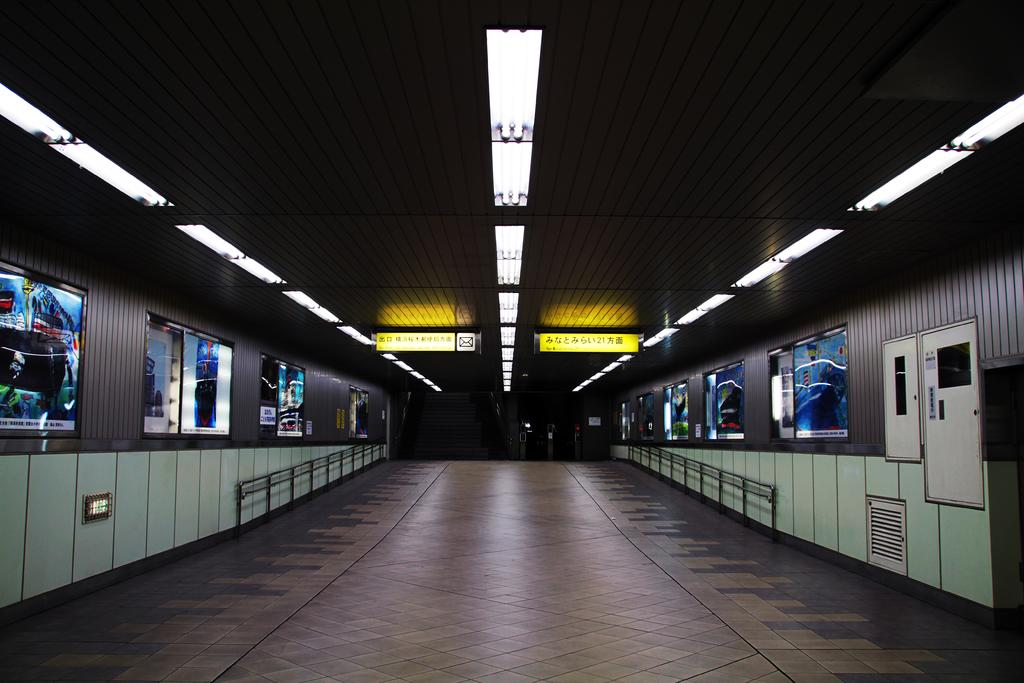What can be seen on the ground in the image? The floor is visible in the image. What type of structures are present in the image? There are fences in the image. What can be used for identification purposes in the image? Name boards are present in the image. What provides illumination in the image? Lights are visible in the image. What is attached to the walls in the image? Boards are attached to walls in the image. What else can be seen in the image besides the mentioned elements? There are objects in the image. How would you describe the overall lighting condition in the image? The background of the image is dark. Can you find the receipt for the surprise party in the image? There is no mention of a receipt or a surprise party in the image. 